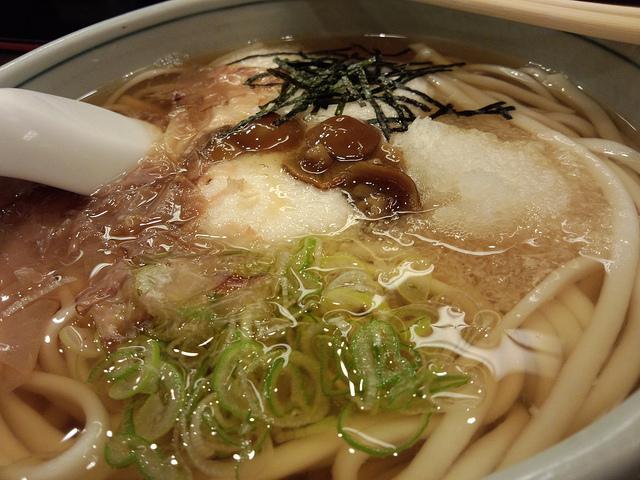Would this be classified as a desert?
Short answer required. No. Are there noodles in this dish?
Quick response, please. Yes. Is there a utensil in the pot?
Answer briefly. Yes. 